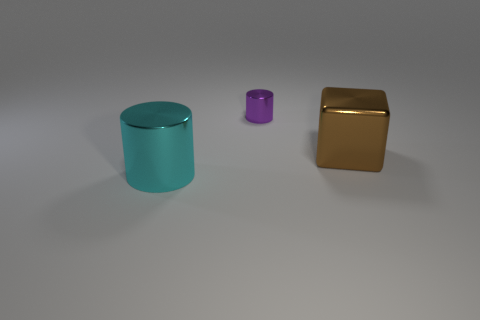Add 3 purple metal things. How many objects exist? 6 Subtract all cylinders. How many objects are left? 1 Subtract 0 blue balls. How many objects are left? 3 Subtract all large blocks. Subtract all yellow cubes. How many objects are left? 2 Add 3 brown things. How many brown things are left? 4 Add 1 tiny purple metal things. How many tiny purple metal things exist? 2 